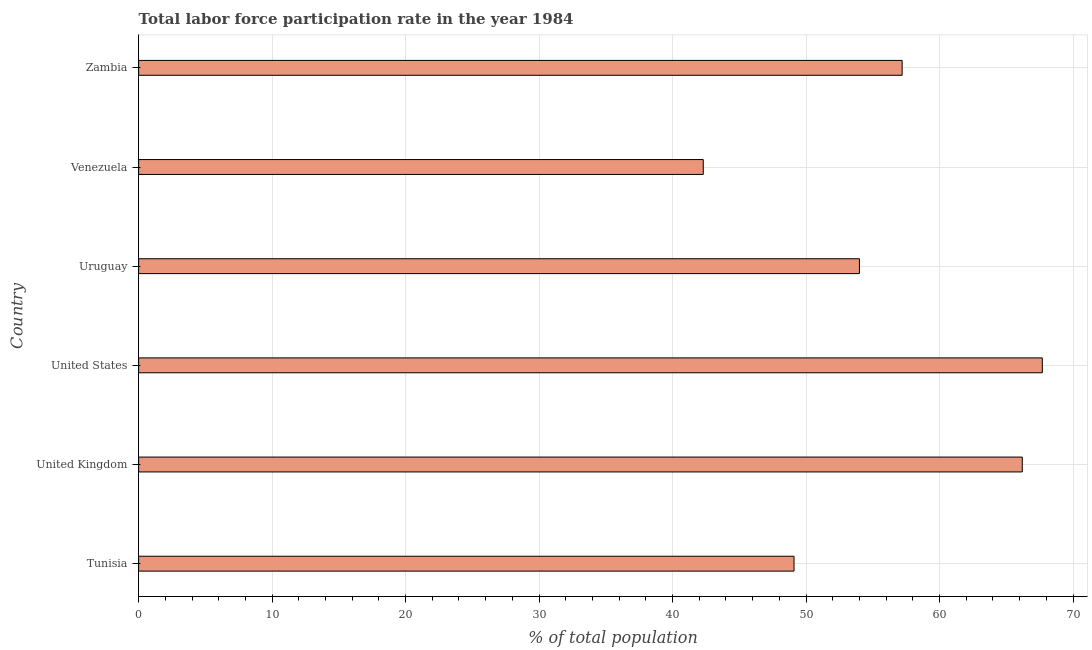Does the graph contain any zero values?
Give a very brief answer. No. Does the graph contain grids?
Provide a short and direct response. Yes. What is the title of the graph?
Offer a terse response. Total labor force participation rate in the year 1984. What is the label or title of the X-axis?
Your response must be concise. % of total population. What is the total labor force participation rate in United States?
Keep it short and to the point. 67.7. Across all countries, what is the maximum total labor force participation rate?
Make the answer very short. 67.7. Across all countries, what is the minimum total labor force participation rate?
Your answer should be compact. 42.3. In which country was the total labor force participation rate minimum?
Your response must be concise. Venezuela. What is the sum of the total labor force participation rate?
Offer a terse response. 336.5. What is the difference between the total labor force participation rate in United Kingdom and United States?
Your response must be concise. -1.5. What is the average total labor force participation rate per country?
Your response must be concise. 56.08. What is the median total labor force participation rate?
Make the answer very short. 55.6. What is the ratio of the total labor force participation rate in Tunisia to that in Zambia?
Keep it short and to the point. 0.86. Is the total labor force participation rate in Uruguay less than that in Zambia?
Your response must be concise. Yes. Is the sum of the total labor force participation rate in United Kingdom and Zambia greater than the maximum total labor force participation rate across all countries?
Offer a terse response. Yes. What is the difference between the highest and the lowest total labor force participation rate?
Give a very brief answer. 25.4. How many bars are there?
Make the answer very short. 6. Are all the bars in the graph horizontal?
Offer a very short reply. Yes. What is the difference between two consecutive major ticks on the X-axis?
Keep it short and to the point. 10. Are the values on the major ticks of X-axis written in scientific E-notation?
Ensure brevity in your answer.  No. What is the % of total population of Tunisia?
Your answer should be very brief. 49.1. What is the % of total population of United Kingdom?
Offer a very short reply. 66.2. What is the % of total population in United States?
Your response must be concise. 67.7. What is the % of total population of Venezuela?
Your answer should be compact. 42.3. What is the % of total population in Zambia?
Provide a succinct answer. 57.2. What is the difference between the % of total population in Tunisia and United Kingdom?
Make the answer very short. -17.1. What is the difference between the % of total population in Tunisia and United States?
Offer a very short reply. -18.6. What is the difference between the % of total population in Tunisia and Uruguay?
Your response must be concise. -4.9. What is the difference between the % of total population in Tunisia and Zambia?
Give a very brief answer. -8.1. What is the difference between the % of total population in United Kingdom and United States?
Offer a very short reply. -1.5. What is the difference between the % of total population in United Kingdom and Venezuela?
Provide a short and direct response. 23.9. What is the difference between the % of total population in United States and Uruguay?
Provide a succinct answer. 13.7. What is the difference between the % of total population in United States and Venezuela?
Give a very brief answer. 25.4. What is the difference between the % of total population in Uruguay and Venezuela?
Ensure brevity in your answer.  11.7. What is the difference between the % of total population in Venezuela and Zambia?
Keep it short and to the point. -14.9. What is the ratio of the % of total population in Tunisia to that in United Kingdom?
Keep it short and to the point. 0.74. What is the ratio of the % of total population in Tunisia to that in United States?
Make the answer very short. 0.72. What is the ratio of the % of total population in Tunisia to that in Uruguay?
Make the answer very short. 0.91. What is the ratio of the % of total population in Tunisia to that in Venezuela?
Keep it short and to the point. 1.16. What is the ratio of the % of total population in Tunisia to that in Zambia?
Offer a terse response. 0.86. What is the ratio of the % of total population in United Kingdom to that in United States?
Provide a short and direct response. 0.98. What is the ratio of the % of total population in United Kingdom to that in Uruguay?
Your answer should be very brief. 1.23. What is the ratio of the % of total population in United Kingdom to that in Venezuela?
Your answer should be compact. 1.56. What is the ratio of the % of total population in United Kingdom to that in Zambia?
Ensure brevity in your answer.  1.16. What is the ratio of the % of total population in United States to that in Uruguay?
Provide a succinct answer. 1.25. What is the ratio of the % of total population in United States to that in Venezuela?
Your answer should be very brief. 1.6. What is the ratio of the % of total population in United States to that in Zambia?
Ensure brevity in your answer.  1.18. What is the ratio of the % of total population in Uruguay to that in Venezuela?
Offer a terse response. 1.28. What is the ratio of the % of total population in Uruguay to that in Zambia?
Keep it short and to the point. 0.94. What is the ratio of the % of total population in Venezuela to that in Zambia?
Provide a short and direct response. 0.74. 